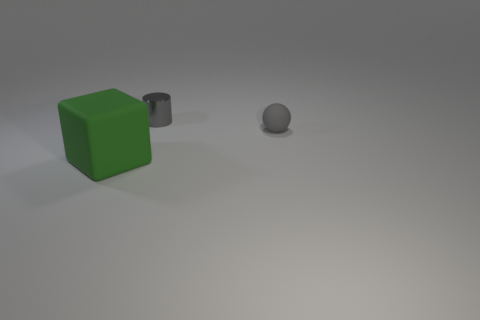Add 3 big cubes. How many objects exist? 6 Subtract all cubes. How many objects are left? 2 Subtract 0 green cylinders. How many objects are left? 3 Subtract all big green matte cubes. Subtract all large green blocks. How many objects are left? 1 Add 1 big matte objects. How many big matte objects are left? 2 Add 1 matte cylinders. How many matte cylinders exist? 1 